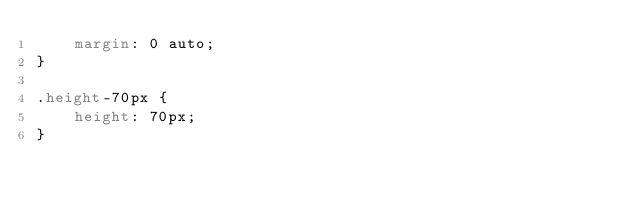<code> <loc_0><loc_0><loc_500><loc_500><_CSS_>    margin: 0 auto;
}

.height-70px {
    height: 70px;
}
</code> 